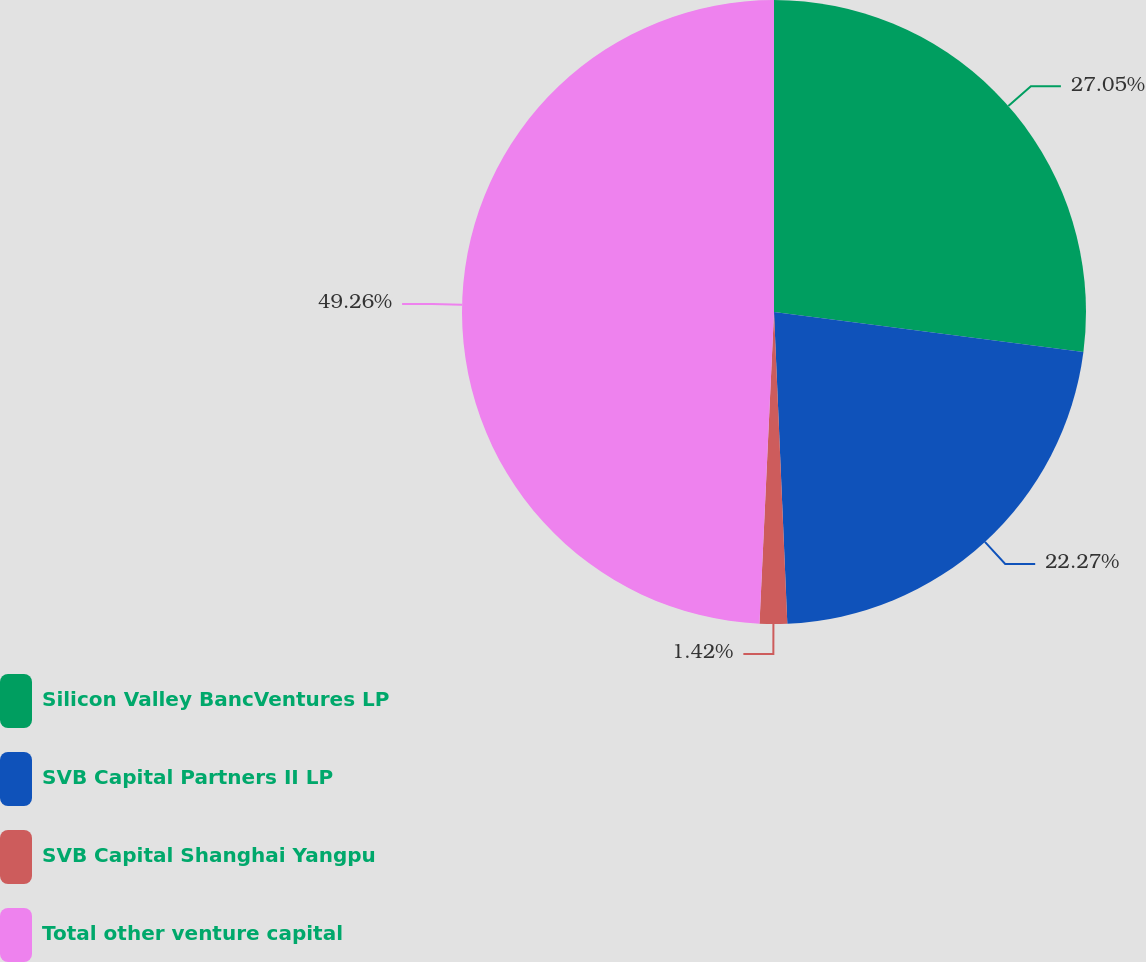<chart> <loc_0><loc_0><loc_500><loc_500><pie_chart><fcel>Silicon Valley BancVentures LP<fcel>SVB Capital Partners II LP<fcel>SVB Capital Shanghai Yangpu<fcel>Total other venture capital<nl><fcel>27.05%<fcel>22.27%<fcel>1.42%<fcel>49.26%<nl></chart> 